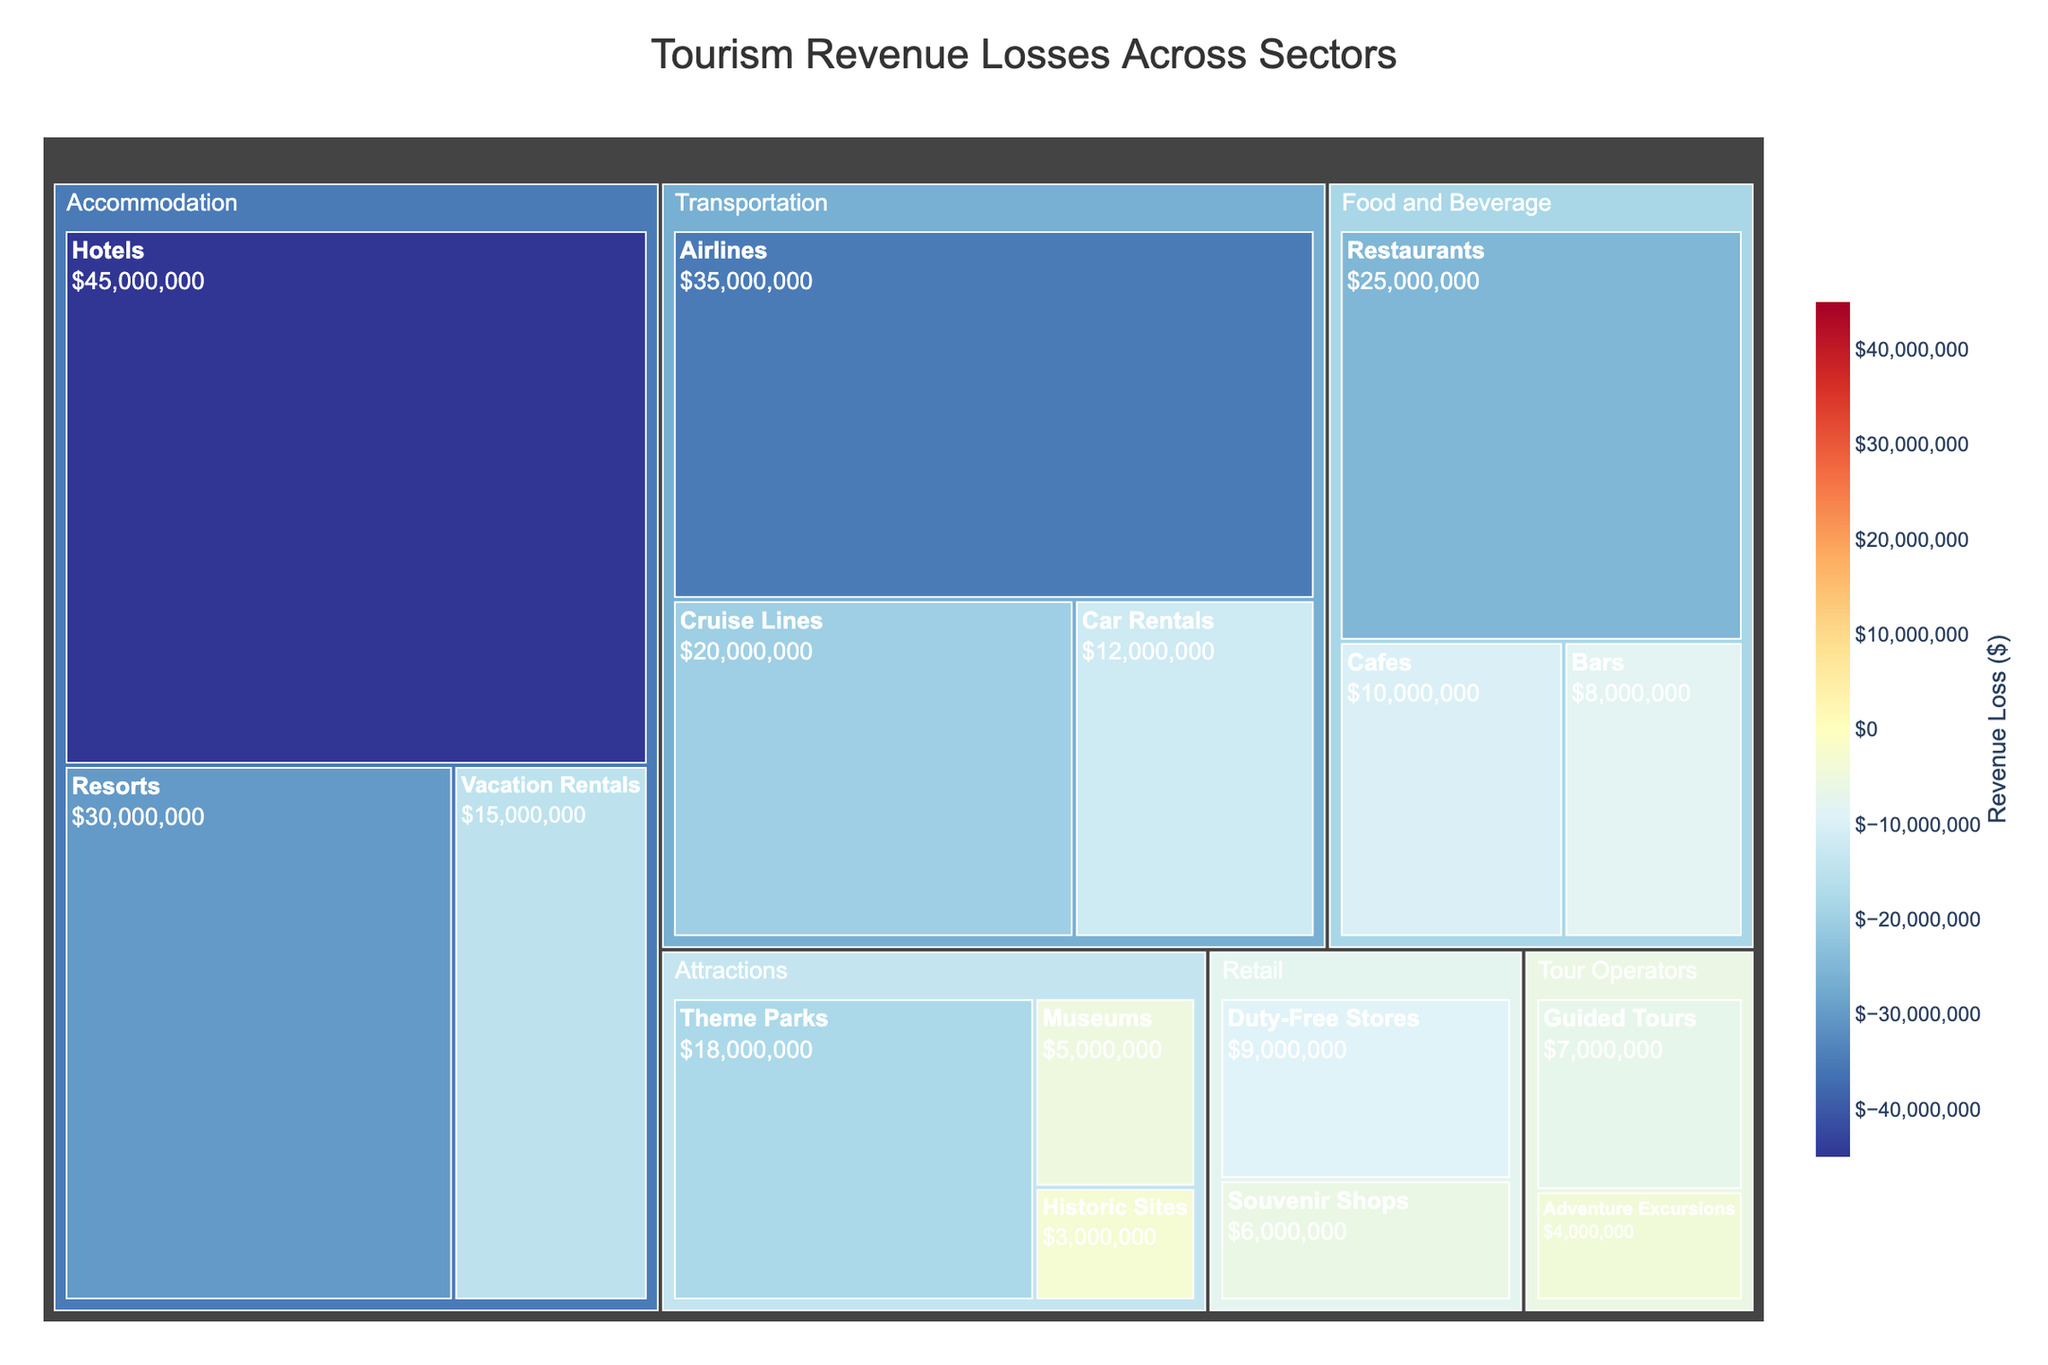What is the title of the figure? The title of the figure can be found at the top and provides a direct description of what the chart represents.
Answer: Tourism Revenue Losses Across Sectors Which sector has the highest revenue loss? By looking at the size of the sections in the treemap, you can identify which sector has the largest block area indicating the highest revenue loss.
Answer: Accommodation Among the sub-sectors within 'Transportation,' which one suffered the highest revenue loss? Within the 'Transportation' section of the treemap, the sub-sector with the largest block represents the highest revenue loss.
Answer: Airlines How much is the total revenue loss for the 'Food and Beverage' sector? Sum the absolute values of revenue losses for all sub-sectors under 'Food and Beverage': $25,000,000 (Restaurants) + $10,000,000 (Cafes) + $8,000,000 (Bars).
Answer: $43,000,000 Which sub-sector has the smallest revenue loss? By finding the smallest block within all sectors and subsections in the treemap, you can identify the sub-sector with the smallest revenue loss.
Answer: Historic Sites Compare the revenue loss between 'Restaurants' and 'Cruise Lines.' Which one is greater and by how much? Look at the blocks representing 'Restaurants' and 'Cruise Lines' and compare their revenue losses, calculating the difference: $25,000,000 (Restaurants) - $20,000,000 (Cruise Lines).
Answer: Restaurants by $5,000,000 What is the average revenue loss among all subsectors in the 'Accommodation' sector? Calculate the mean of the absolute values of revenue losses for Hotels, Resorts, and Vacation Rentals: ($45,000,000 + $30,000,000 + $15,000,000) / 3.
Answer: $30,000,000 Is the revenue loss for 'Duty-Free Stores' less than the combined revenue loss of 'Guided Tours' and 'Adventure Excursions'? Compare the revenue loss of 'Duty-Free Stores' ($9,000,000) with the sum of 'Guided Tours' and 'Adventure Excursions' ($7,000,000 + $4,000,000): $9,000,000 < $11,000,000.
Answer: Yes Which sector shows the most division in terms of sub-sector revenue losses? A sector with a large number of differently sized blocks indicates significant division in revenue losses among sub-sectors.
Answer: Food and Beverage Calculate the combined revenue loss for 'Attractions'. Sum the absolute values of revenue losses for all sub-sectors under 'Attractions': $18,000,000 (Theme Parks) + $5,000,000 (Museums) + $3,000,000 (Historic Sites).
Answer: $26,000,000 